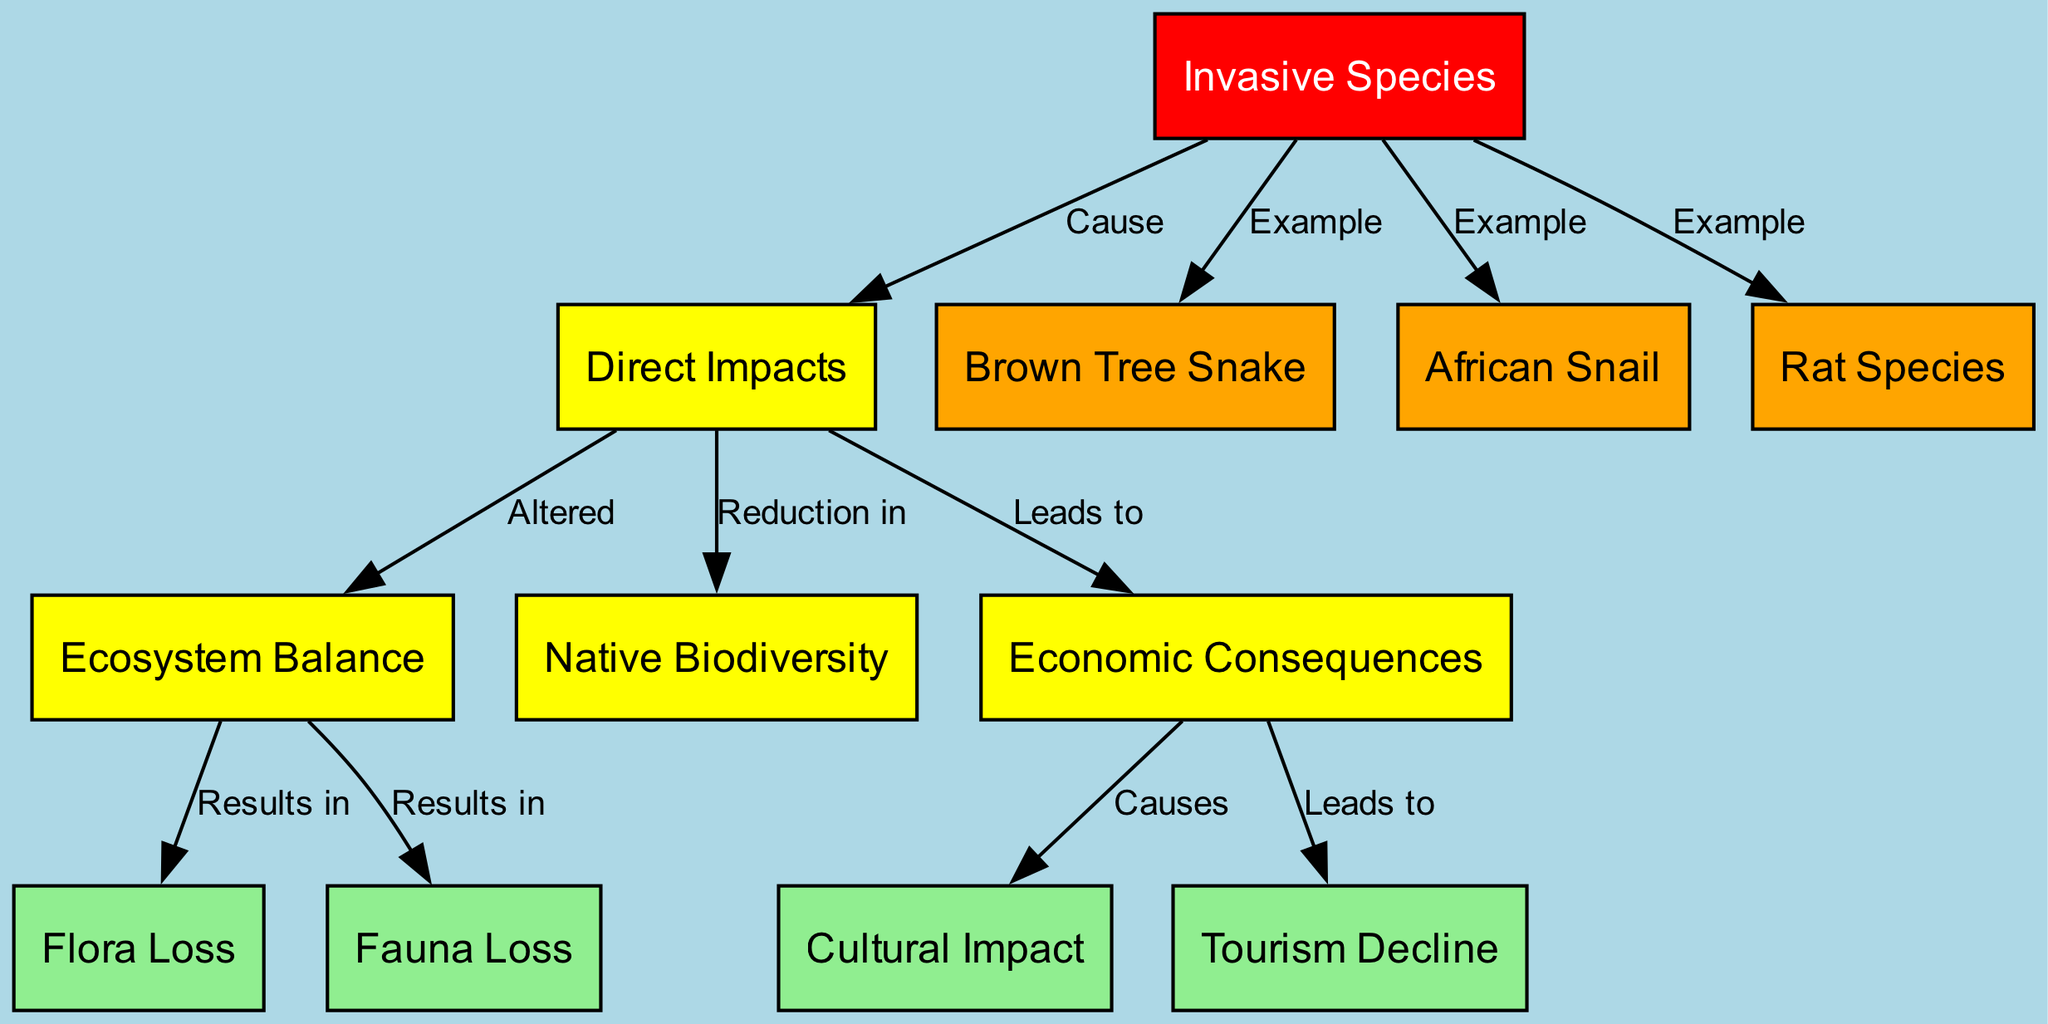What are examples of invasive species listed in the diagram? The diagram specifically mentions three invasive species: the Brown Tree Snake, African Snail, and Rat Species. These are included under the "Example" relationships linking from "Invasive Species."
Answer: Brown Tree Snake, African Snail, Rat Species How many nodes are present in the diagram? The diagram contains a total of 12 nodes that represent various concepts related to the ecological impact of invasive species, including "Invasive Species," "Direct Impacts," and various forms of biodiversity loss.
Answer: 12 What do invasive species cause in terms of direct impacts? The direct impacts caused by invasive species, as per the diagram, include alterations in ecosystem balance and reductions in native biodiversity. This follows the flow from "Invasive Species" to "Direct Impacts."
Answer: Altered, Reduction in What results from the alteration of ecosystem balance? The alteration of ecosystem balance leads to flora loss and fauna loss, as indicated by the edges resulting from "Ecosystem Balance" to "Flora Loss" and "Fauna Loss."
Answer: Flora Loss, Fauna Loss What is one economic consequence of invasive species? One economic consequence highlighted in the diagram is cultural impact, which occurs as a result of broader economic consequences linked to the direct impacts of invasive species.
Answer: Cultural Impact How does the economic consequence lead to a decline in tourism? The economic consequences, stemming from the direct impacts of invasive species, ultimately leads to a decline in tourism. This can be followed through the connections from "Economic Consequences" to "Tourism Decline."
Answer: Decline in Tourism What are the two main losses resulting from changes in ecosystem balance? The two main losses resulting from these changes are flora loss and fauna loss, which follow from the impacts on ecosystem balance, illustrating the negative effects on biodiversity.
Answer: Flora Loss, Fauna Loss What type of impacts are caused directly by invasive species? Invasive species are shown to cause direct impacts that alter the ecosystem balance and lead to reductions in native biodiversity, illustrating their harmful effects.
Answer: Direct Impacts 